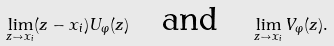<formula> <loc_0><loc_0><loc_500><loc_500>\lim _ { z \to x _ { i } } ( z - x _ { i } ) U _ { \varphi } ( z ) \quad \text {and} \quad \lim _ { z \to x _ { i } } V _ { \varphi } ( z ) .</formula> 